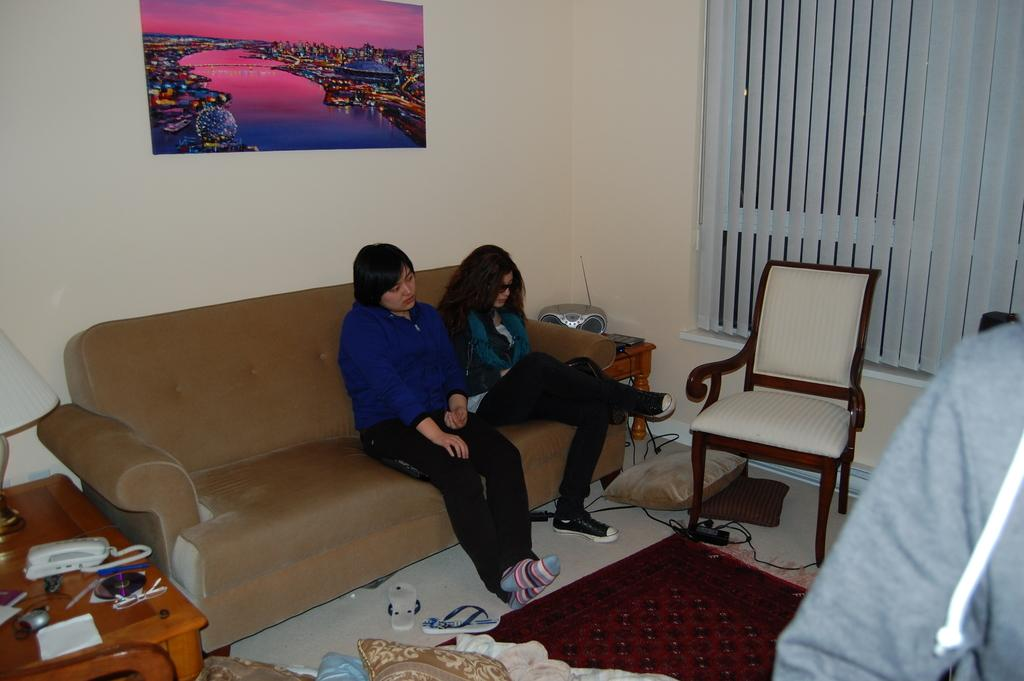How many people are in the image? There are two women in the image. What are the women doing in the image? The women are sitting on a sofa. What type of eggnog can be seen on the shelf in the image? There is no shelf or eggnog present in the image. How many girls are in the image? The image features two women, not girls. 